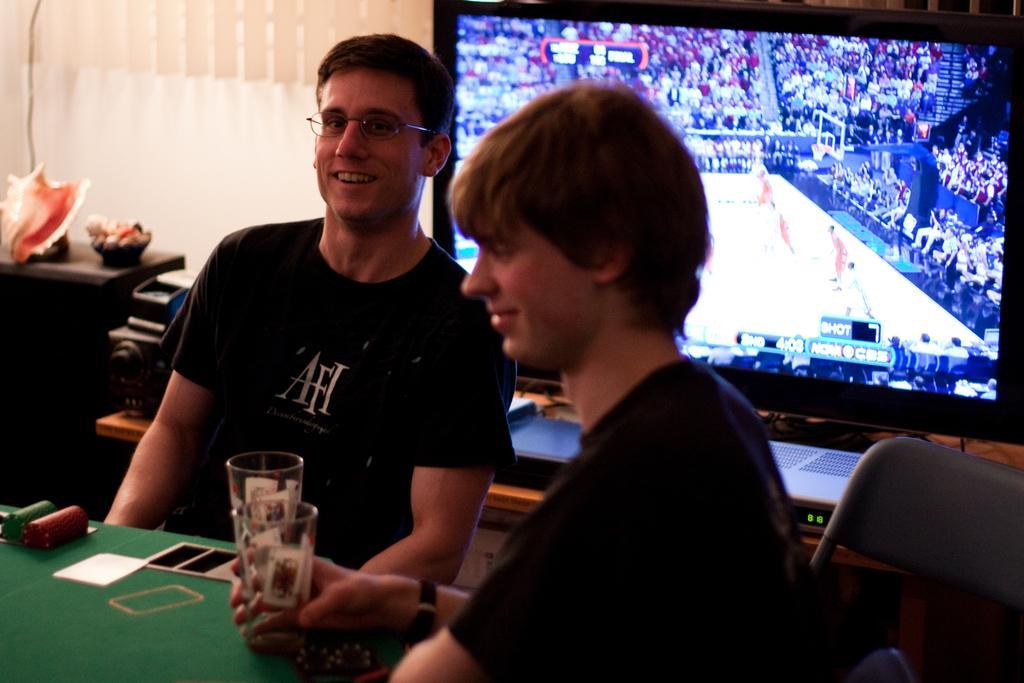In one or two sentences, can you explain what this image depicts? On the left side, there is a person in black color T-shirt, smiling, sitting on a chair and holding a glass. Beside him, there is a table, on which there are some objects and there is a person who is in black color T-shirt, smiling and sitting. In the background, there is a monitor, there is a wall and there are some objects. 